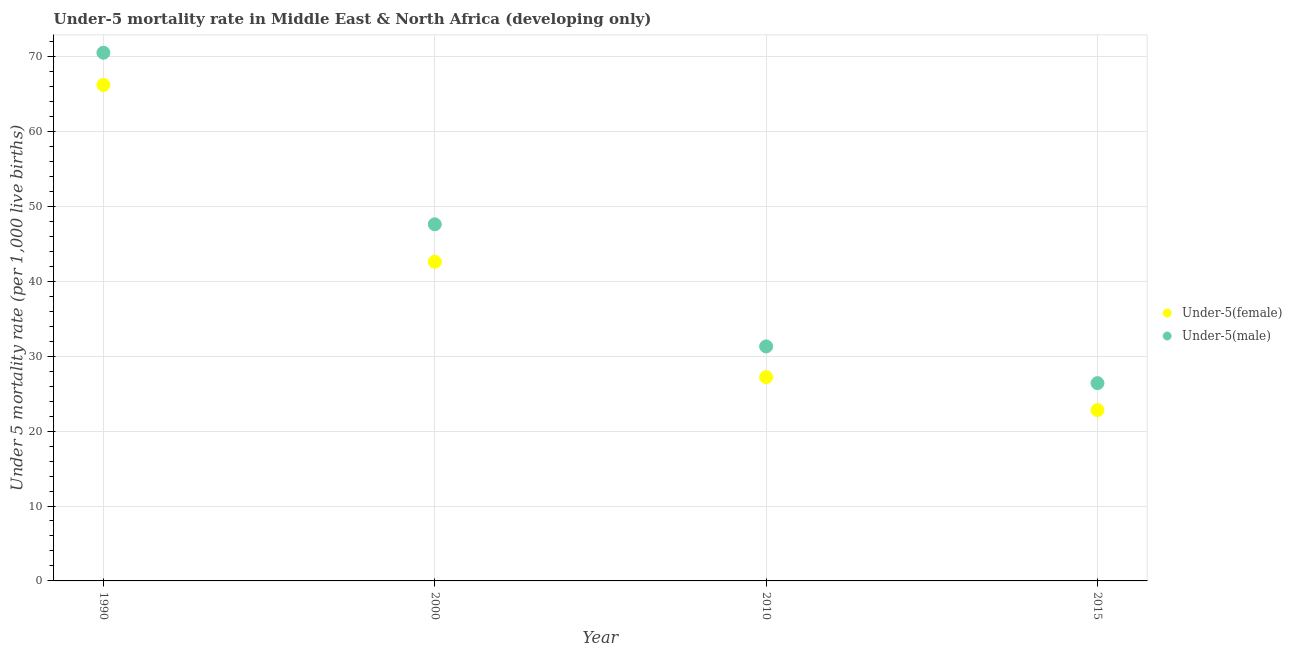Is the number of dotlines equal to the number of legend labels?
Give a very brief answer. Yes. What is the under-5 male mortality rate in 2015?
Offer a very short reply. 26.4. Across all years, what is the maximum under-5 male mortality rate?
Your answer should be compact. 70.5. Across all years, what is the minimum under-5 female mortality rate?
Provide a short and direct response. 22.8. In which year was the under-5 female mortality rate maximum?
Make the answer very short. 1990. In which year was the under-5 male mortality rate minimum?
Your answer should be very brief. 2015. What is the total under-5 female mortality rate in the graph?
Your answer should be compact. 158.8. What is the difference between the under-5 male mortality rate in 1990 and that in 2015?
Give a very brief answer. 44.1. What is the difference between the under-5 male mortality rate in 2010 and the under-5 female mortality rate in 1990?
Offer a very short reply. -34.9. What is the average under-5 female mortality rate per year?
Give a very brief answer. 39.7. In the year 2000, what is the difference between the under-5 male mortality rate and under-5 female mortality rate?
Your response must be concise. 5. In how many years, is the under-5 male mortality rate greater than 58?
Your answer should be very brief. 1. What is the ratio of the under-5 male mortality rate in 1990 to that in 2010?
Your response must be concise. 2.25. Is the under-5 male mortality rate in 2010 less than that in 2015?
Provide a succinct answer. No. Is the difference between the under-5 male mortality rate in 2000 and 2010 greater than the difference between the under-5 female mortality rate in 2000 and 2010?
Give a very brief answer. Yes. What is the difference between the highest and the second highest under-5 male mortality rate?
Keep it short and to the point. 22.9. What is the difference between the highest and the lowest under-5 female mortality rate?
Give a very brief answer. 43.4. Is the sum of the under-5 female mortality rate in 2000 and 2015 greater than the maximum under-5 male mortality rate across all years?
Offer a very short reply. No. Is the under-5 female mortality rate strictly greater than the under-5 male mortality rate over the years?
Offer a very short reply. No. Is the under-5 female mortality rate strictly less than the under-5 male mortality rate over the years?
Provide a short and direct response. Yes. Does the graph contain any zero values?
Your answer should be very brief. No. Does the graph contain grids?
Provide a short and direct response. Yes. What is the title of the graph?
Give a very brief answer. Under-5 mortality rate in Middle East & North Africa (developing only). Does "Personal remittances" appear as one of the legend labels in the graph?
Provide a short and direct response. No. What is the label or title of the Y-axis?
Your answer should be compact. Under 5 mortality rate (per 1,0 live births). What is the Under 5 mortality rate (per 1,000 live births) of Under-5(female) in 1990?
Keep it short and to the point. 66.2. What is the Under 5 mortality rate (per 1,000 live births) in Under-5(male) in 1990?
Offer a terse response. 70.5. What is the Under 5 mortality rate (per 1,000 live births) of Under-5(female) in 2000?
Ensure brevity in your answer.  42.6. What is the Under 5 mortality rate (per 1,000 live births) in Under-5(male) in 2000?
Your answer should be compact. 47.6. What is the Under 5 mortality rate (per 1,000 live births) in Under-5(female) in 2010?
Your response must be concise. 27.2. What is the Under 5 mortality rate (per 1,000 live births) of Under-5(male) in 2010?
Offer a very short reply. 31.3. What is the Under 5 mortality rate (per 1,000 live births) of Under-5(female) in 2015?
Keep it short and to the point. 22.8. What is the Under 5 mortality rate (per 1,000 live births) in Under-5(male) in 2015?
Offer a very short reply. 26.4. Across all years, what is the maximum Under 5 mortality rate (per 1,000 live births) in Under-5(female)?
Offer a very short reply. 66.2. Across all years, what is the maximum Under 5 mortality rate (per 1,000 live births) of Under-5(male)?
Provide a short and direct response. 70.5. Across all years, what is the minimum Under 5 mortality rate (per 1,000 live births) in Under-5(female)?
Make the answer very short. 22.8. Across all years, what is the minimum Under 5 mortality rate (per 1,000 live births) of Under-5(male)?
Give a very brief answer. 26.4. What is the total Under 5 mortality rate (per 1,000 live births) in Under-5(female) in the graph?
Keep it short and to the point. 158.8. What is the total Under 5 mortality rate (per 1,000 live births) of Under-5(male) in the graph?
Your answer should be very brief. 175.8. What is the difference between the Under 5 mortality rate (per 1,000 live births) in Under-5(female) in 1990 and that in 2000?
Offer a terse response. 23.6. What is the difference between the Under 5 mortality rate (per 1,000 live births) of Under-5(male) in 1990 and that in 2000?
Your response must be concise. 22.9. What is the difference between the Under 5 mortality rate (per 1,000 live births) of Under-5(male) in 1990 and that in 2010?
Make the answer very short. 39.2. What is the difference between the Under 5 mortality rate (per 1,000 live births) of Under-5(female) in 1990 and that in 2015?
Offer a very short reply. 43.4. What is the difference between the Under 5 mortality rate (per 1,000 live births) of Under-5(male) in 1990 and that in 2015?
Make the answer very short. 44.1. What is the difference between the Under 5 mortality rate (per 1,000 live births) in Under-5(female) in 2000 and that in 2010?
Keep it short and to the point. 15.4. What is the difference between the Under 5 mortality rate (per 1,000 live births) of Under-5(female) in 2000 and that in 2015?
Provide a short and direct response. 19.8. What is the difference between the Under 5 mortality rate (per 1,000 live births) of Under-5(male) in 2000 and that in 2015?
Make the answer very short. 21.2. What is the difference between the Under 5 mortality rate (per 1,000 live births) of Under-5(female) in 1990 and the Under 5 mortality rate (per 1,000 live births) of Under-5(male) in 2000?
Provide a short and direct response. 18.6. What is the difference between the Under 5 mortality rate (per 1,000 live births) of Under-5(female) in 1990 and the Under 5 mortality rate (per 1,000 live births) of Under-5(male) in 2010?
Your answer should be very brief. 34.9. What is the difference between the Under 5 mortality rate (per 1,000 live births) of Under-5(female) in 1990 and the Under 5 mortality rate (per 1,000 live births) of Under-5(male) in 2015?
Provide a succinct answer. 39.8. What is the difference between the Under 5 mortality rate (per 1,000 live births) in Under-5(female) in 2000 and the Under 5 mortality rate (per 1,000 live births) in Under-5(male) in 2015?
Your response must be concise. 16.2. What is the difference between the Under 5 mortality rate (per 1,000 live births) of Under-5(female) in 2010 and the Under 5 mortality rate (per 1,000 live births) of Under-5(male) in 2015?
Provide a succinct answer. 0.8. What is the average Under 5 mortality rate (per 1,000 live births) in Under-5(female) per year?
Ensure brevity in your answer.  39.7. What is the average Under 5 mortality rate (per 1,000 live births) of Under-5(male) per year?
Your answer should be compact. 43.95. In the year 2010, what is the difference between the Under 5 mortality rate (per 1,000 live births) of Under-5(female) and Under 5 mortality rate (per 1,000 live births) of Under-5(male)?
Provide a short and direct response. -4.1. What is the ratio of the Under 5 mortality rate (per 1,000 live births) in Under-5(female) in 1990 to that in 2000?
Your answer should be compact. 1.55. What is the ratio of the Under 5 mortality rate (per 1,000 live births) in Under-5(male) in 1990 to that in 2000?
Provide a short and direct response. 1.48. What is the ratio of the Under 5 mortality rate (per 1,000 live births) in Under-5(female) in 1990 to that in 2010?
Give a very brief answer. 2.43. What is the ratio of the Under 5 mortality rate (per 1,000 live births) in Under-5(male) in 1990 to that in 2010?
Provide a succinct answer. 2.25. What is the ratio of the Under 5 mortality rate (per 1,000 live births) of Under-5(female) in 1990 to that in 2015?
Provide a succinct answer. 2.9. What is the ratio of the Under 5 mortality rate (per 1,000 live births) in Under-5(male) in 1990 to that in 2015?
Make the answer very short. 2.67. What is the ratio of the Under 5 mortality rate (per 1,000 live births) of Under-5(female) in 2000 to that in 2010?
Provide a short and direct response. 1.57. What is the ratio of the Under 5 mortality rate (per 1,000 live births) in Under-5(male) in 2000 to that in 2010?
Keep it short and to the point. 1.52. What is the ratio of the Under 5 mortality rate (per 1,000 live births) in Under-5(female) in 2000 to that in 2015?
Offer a terse response. 1.87. What is the ratio of the Under 5 mortality rate (per 1,000 live births) in Under-5(male) in 2000 to that in 2015?
Offer a very short reply. 1.8. What is the ratio of the Under 5 mortality rate (per 1,000 live births) of Under-5(female) in 2010 to that in 2015?
Keep it short and to the point. 1.19. What is the ratio of the Under 5 mortality rate (per 1,000 live births) of Under-5(male) in 2010 to that in 2015?
Your answer should be compact. 1.19. What is the difference between the highest and the second highest Under 5 mortality rate (per 1,000 live births) of Under-5(female)?
Offer a terse response. 23.6. What is the difference between the highest and the second highest Under 5 mortality rate (per 1,000 live births) of Under-5(male)?
Provide a succinct answer. 22.9. What is the difference between the highest and the lowest Under 5 mortality rate (per 1,000 live births) in Under-5(female)?
Provide a succinct answer. 43.4. What is the difference between the highest and the lowest Under 5 mortality rate (per 1,000 live births) of Under-5(male)?
Your answer should be compact. 44.1. 